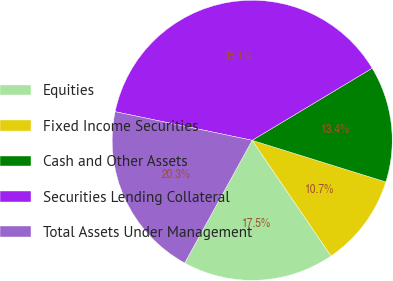Convert chart. <chart><loc_0><loc_0><loc_500><loc_500><pie_chart><fcel>Equities<fcel>Fixed Income Securities<fcel>Cash and Other Assets<fcel>Securities Lending Collateral<fcel>Total Assets Under Management<nl><fcel>17.53%<fcel>10.67%<fcel>13.41%<fcel>38.11%<fcel>20.27%<nl></chart> 